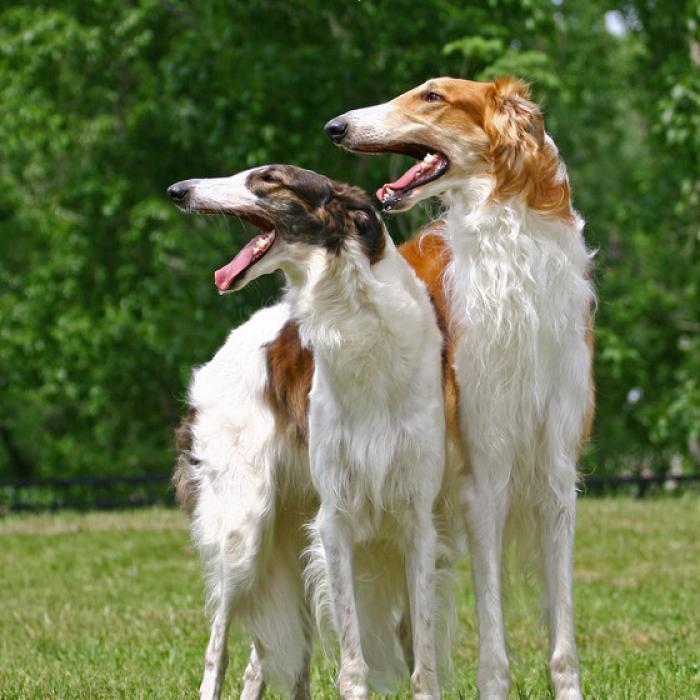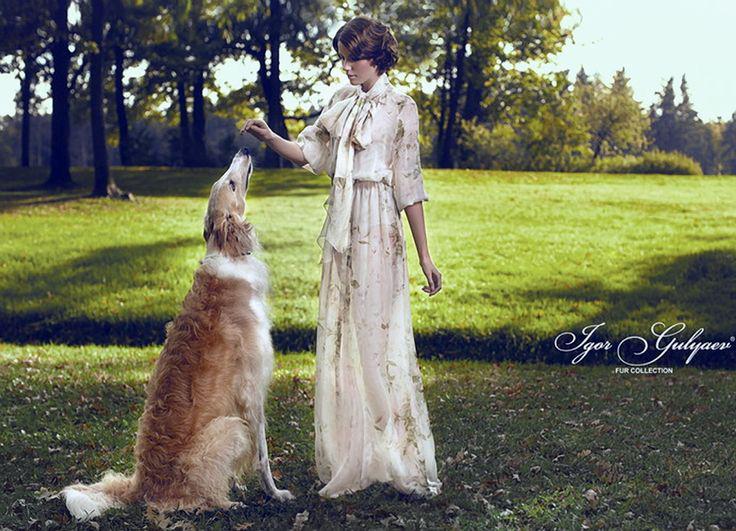The first image is the image on the left, the second image is the image on the right. Analyze the images presented: Is the assertion "A person is training a long haired dog." valid? Answer yes or no. Yes. The first image is the image on the left, the second image is the image on the right. Examine the images to the left and right. Is the description "In at least one image there is a woman whose body is facing left  while showing a tall dog with some white fur." accurate? Answer yes or no. Yes. 